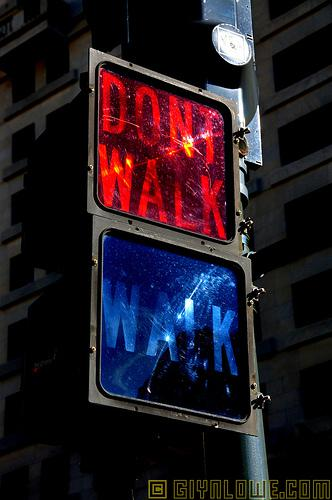Question: when was the picture taken?
Choices:
A. Summer time.
B. In the daytime.
C. Winter time.
D. Night time.
Answer with the letter. Answer: B Question: what do the signs say?
Choices:
A. Walk and Don't walk.
B. One way.
C. Stop.
D. End of road work.
Answer with the letter. Answer: A Question: where was the picture taken?
Choices:
A. At a park.
B. On the freeway.
C. In a parking lot.
D. On a street corner.
Answer with the letter. Answer: D Question: what color is the Walk sign?
Choices:
A. White.
B. Blue and White.
C. Red.
D. Orange.
Answer with the letter. Answer: B 